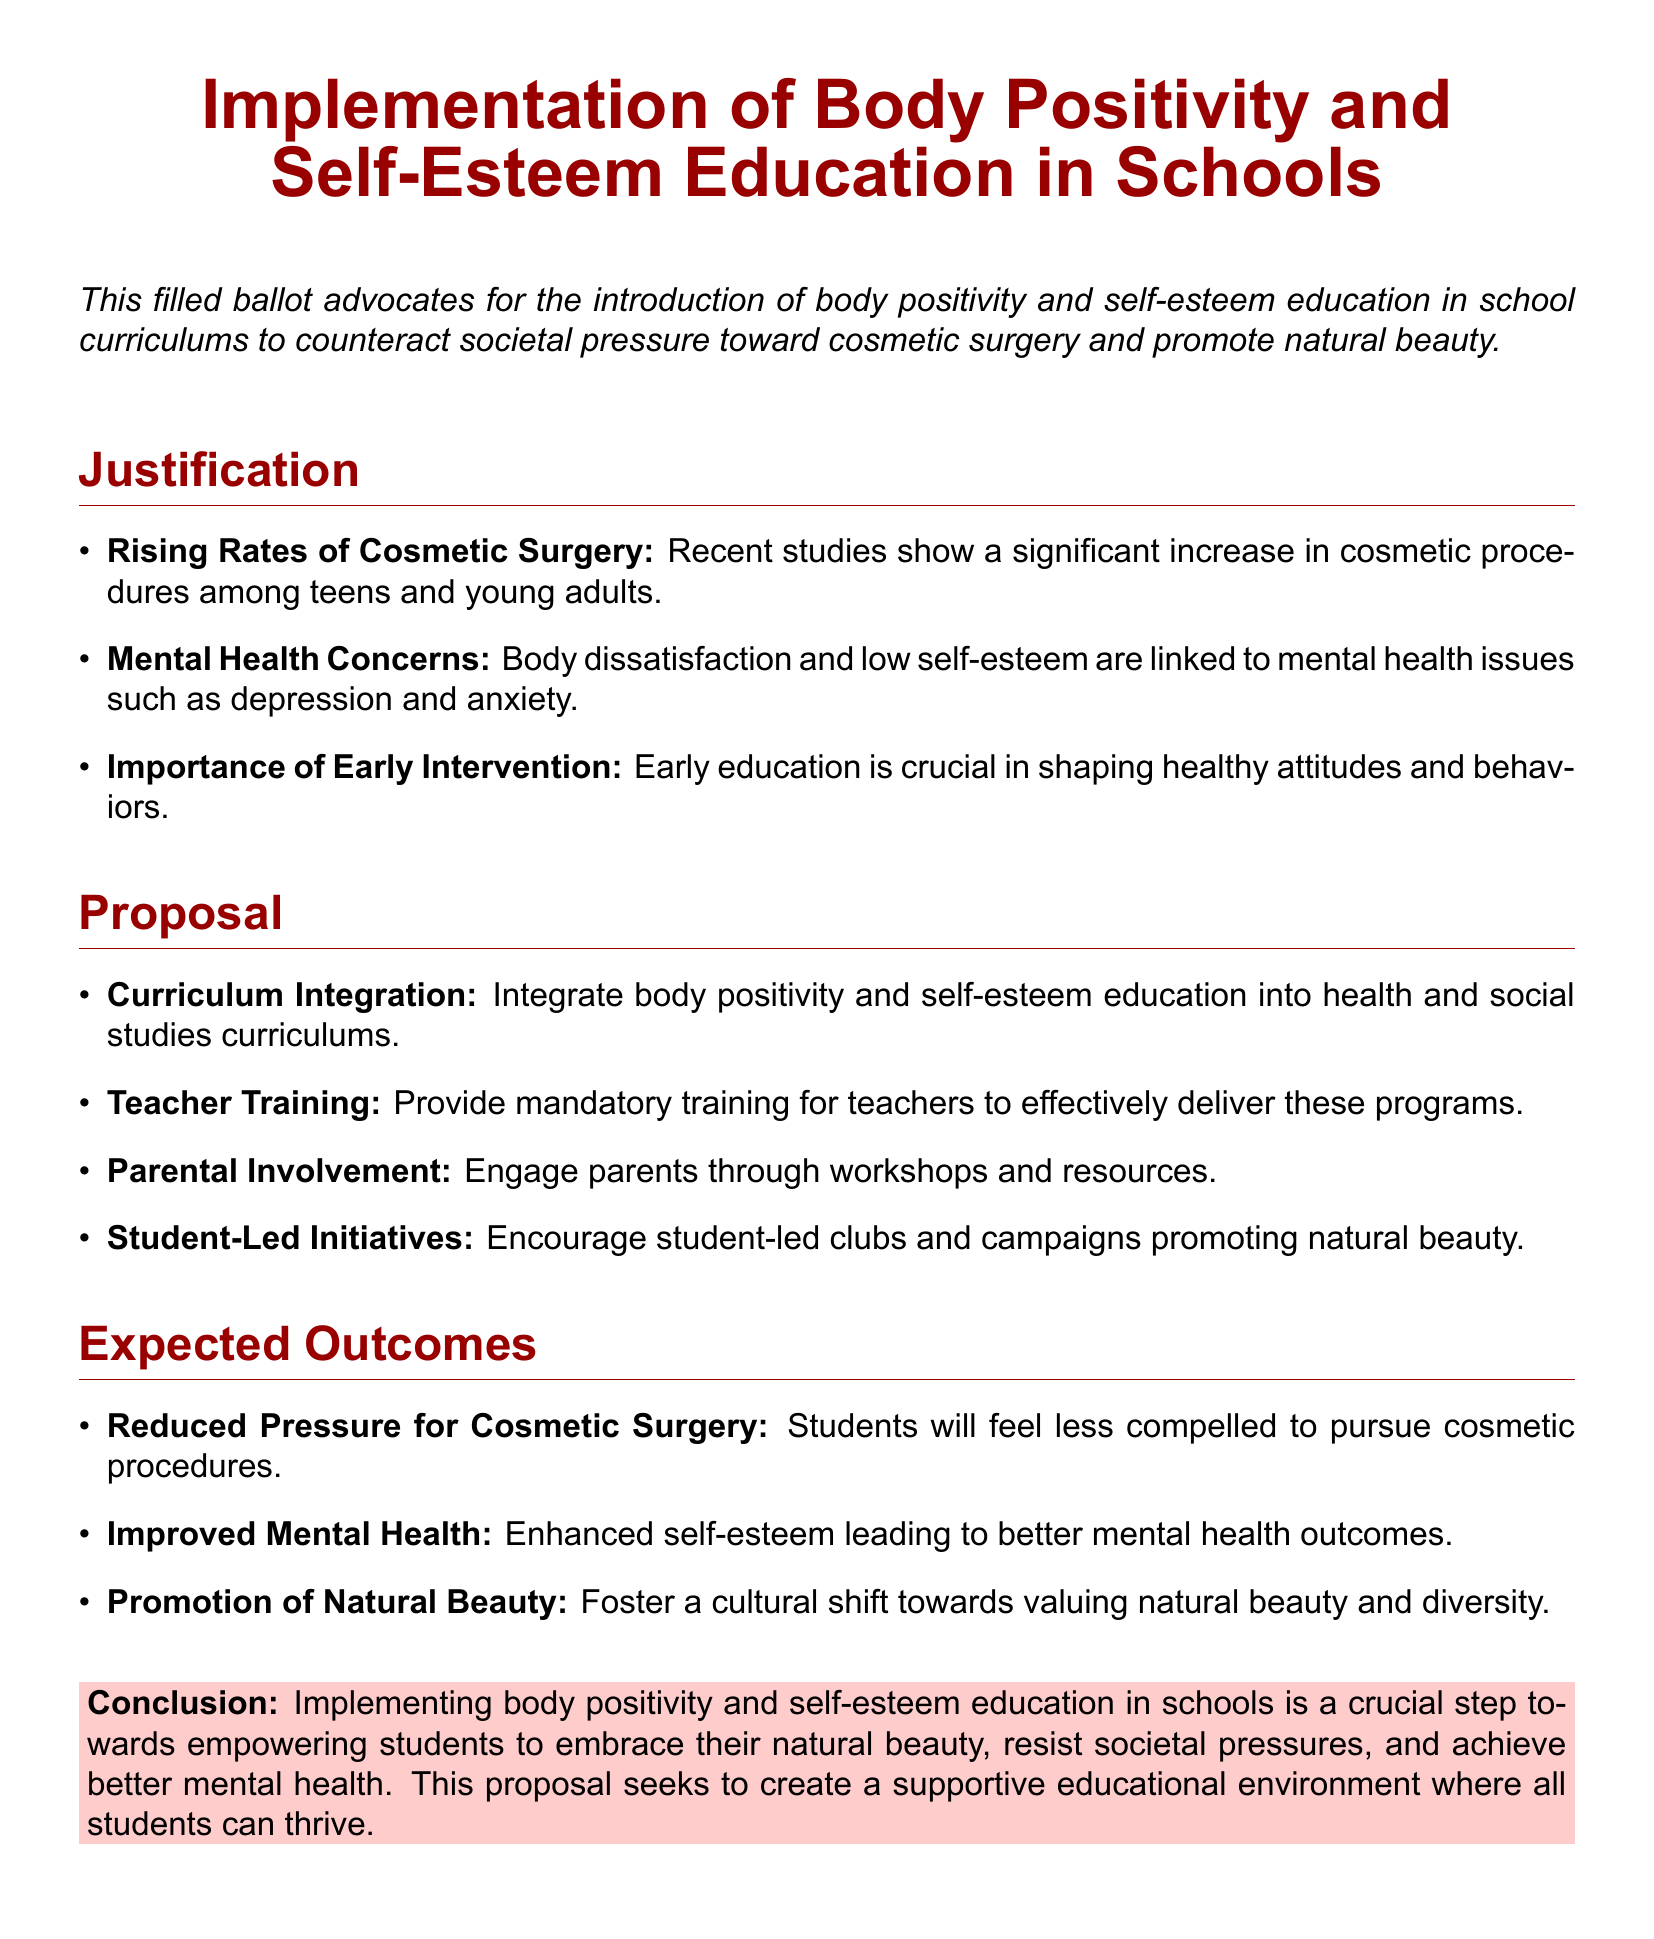What is the main focus of the ballot? The document advocates for the implementation of body positivity and self-esteem education in schools.
Answer: Body positivity and self-esteem education What recent trend is highlighted in the justification? The ballot mentions a significant increase in cosmetic procedures among teens and young adults.
Answer: Rising rates of cosmetic surgery Which mental health issues are linked to body dissatisfaction? The document states that body dissatisfaction and low self-esteem are linked to depression and anxiety.
Answer: Depression and anxiety What is one proposed method for curriculum integration? The proposal suggests integrating body positivity and self-esteem education into health and social studies curriculums.
Answer: Health and social studies curriculums What is one expected outcome of this initiative? An expected outcome mentioned is enhanced self-esteem leading to better mental health outcomes.
Answer: Improved mental health What kind of involvement is encouraged for parents? The document indicates engaging parents through workshops and resources.
Answer: Workshops and resources What is the conclusion's perspective on natural beauty? The conclusion emphasizes empowering students to embrace their natural beauty.
Answer: Embrace their natural beauty How should teachers be prepared to deliver the education? The ballot proposes providing mandatory training for teachers.
Answer: Mandatory training for teachers What type of initiatives are encouraged among students? The document encourages student-led clubs and campaigns promoting natural beauty.
Answer: Student-led clubs and campaigns 